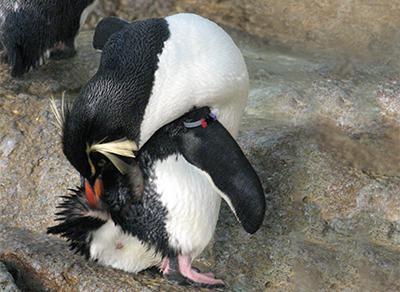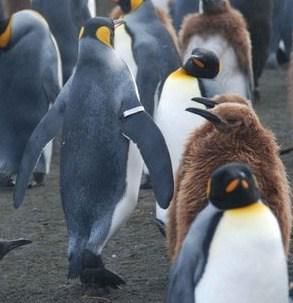The first image is the image on the left, the second image is the image on the right. For the images displayed, is the sentence "There is a total of 1 penguin grooming themselves." factually correct? Answer yes or no. Yes. 